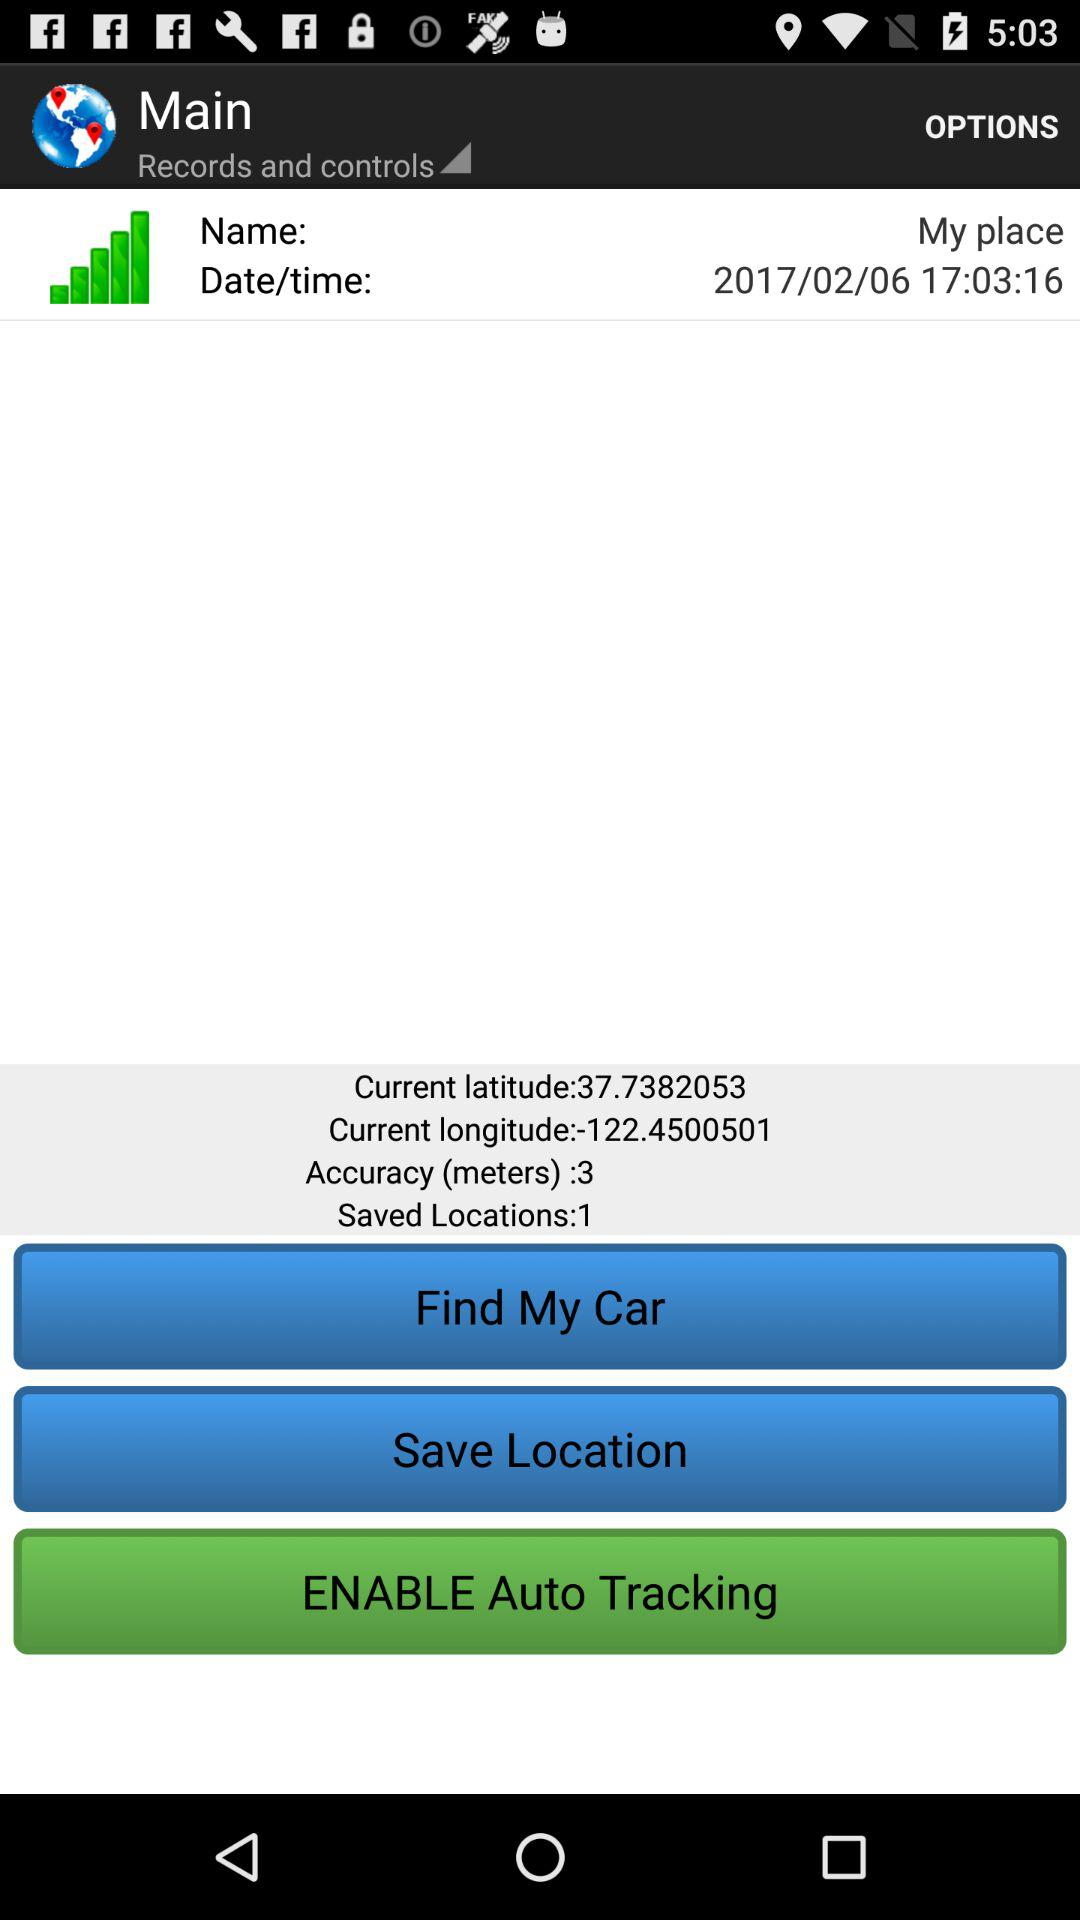What is the current latitude? The current latitude is 37.7382053. 